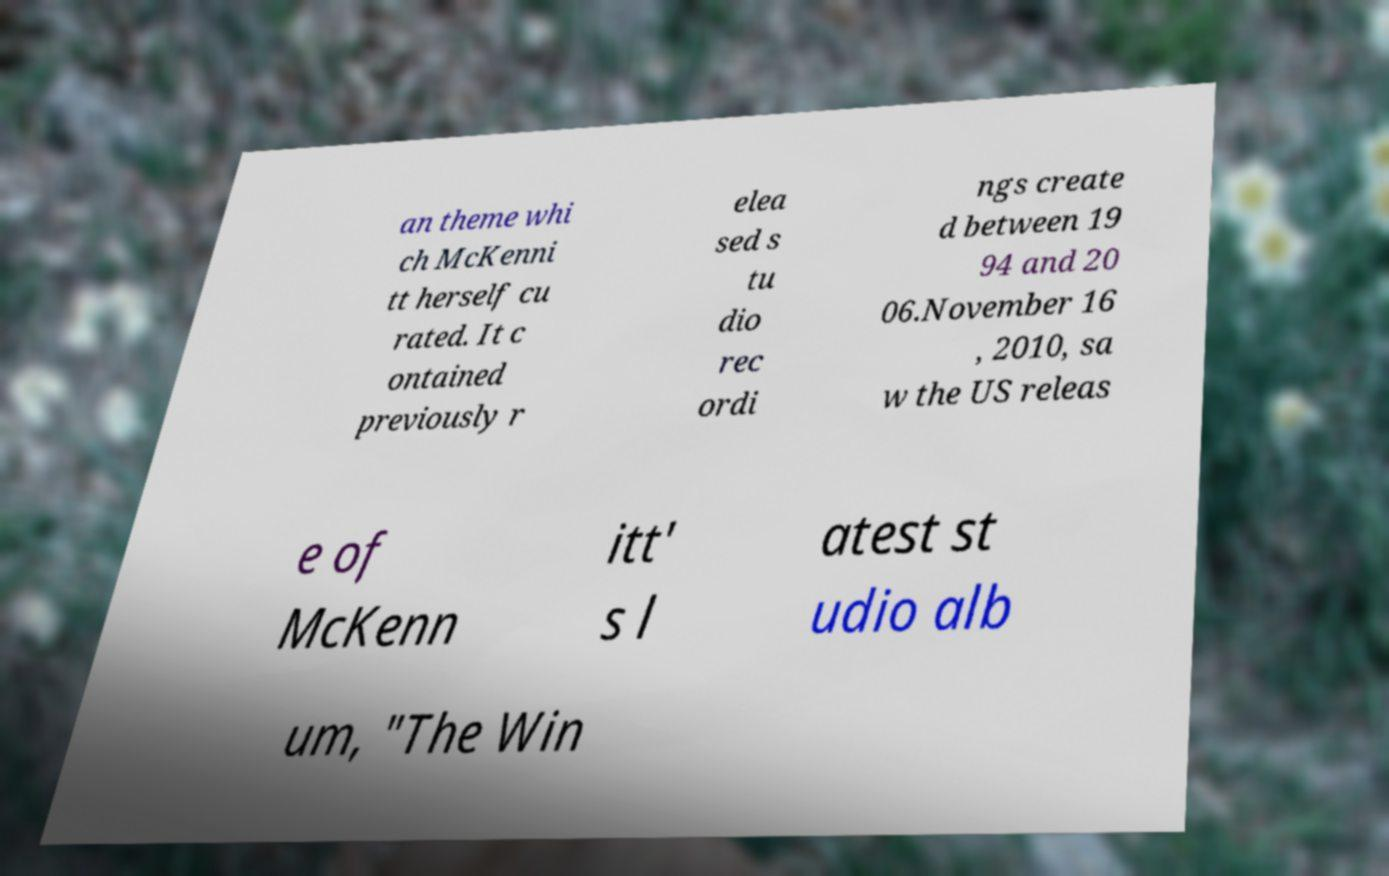Can you read and provide the text displayed in the image?This photo seems to have some interesting text. Can you extract and type it out for me? an theme whi ch McKenni tt herself cu rated. It c ontained previously r elea sed s tu dio rec ordi ngs create d between 19 94 and 20 06.November 16 , 2010, sa w the US releas e of McKenn itt' s l atest st udio alb um, "The Win 